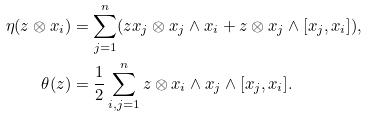<formula> <loc_0><loc_0><loc_500><loc_500>\eta ( z \otimes x _ { i } ) & = \sum _ { j = 1 } ^ { n } ( z x _ { j } \otimes x _ { j } \wedge x _ { i } + z \otimes x _ { j } \wedge [ x _ { j } , x _ { i } ] ) , \\ \theta ( z ) & = \frac { 1 } { 2 } \sum _ { i , j = 1 } ^ { n } z \otimes x _ { i } \wedge x _ { j } \wedge [ x _ { j } , x _ { i } ] .</formula> 